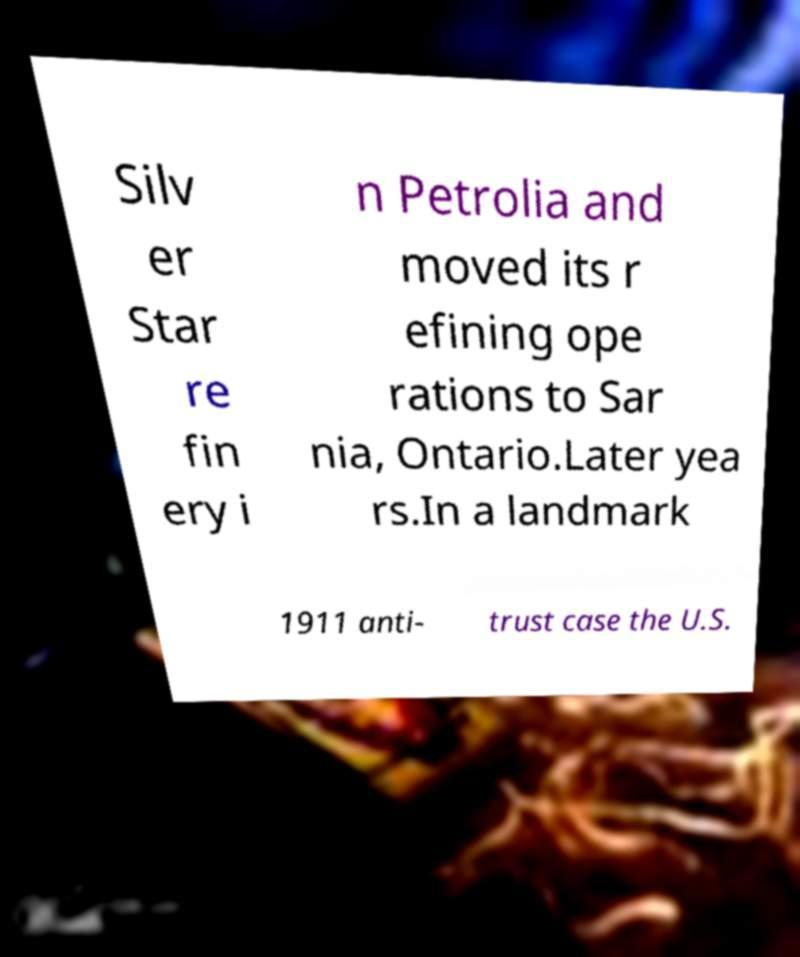Please read and relay the text visible in this image. What does it say? Silv er Star re fin ery i n Petrolia and moved its r efining ope rations to Sar nia, Ontario.Later yea rs.In a landmark 1911 anti- trust case the U.S. 